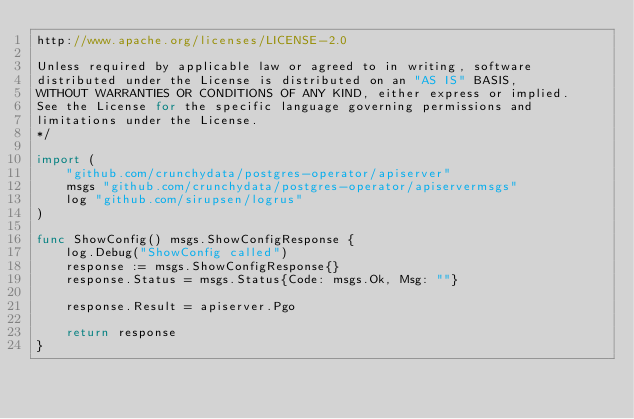Convert code to text. <code><loc_0><loc_0><loc_500><loc_500><_Go_>http://www.apache.org/licenses/LICENSE-2.0

Unless required by applicable law or agreed to in writing, software
distributed under the License is distributed on an "AS IS" BASIS,
WITHOUT WARRANTIES OR CONDITIONS OF ANY KIND, either express or implied.
See the License for the specific language governing permissions and
limitations under the License.
*/

import (
	"github.com/crunchydata/postgres-operator/apiserver"
	msgs "github.com/crunchydata/postgres-operator/apiservermsgs"
	log "github.com/sirupsen/logrus"
)

func ShowConfig() msgs.ShowConfigResponse {
	log.Debug("ShowConfig called")
	response := msgs.ShowConfigResponse{}
	response.Status = msgs.Status{Code: msgs.Ok, Msg: ""}

	response.Result = apiserver.Pgo

	return response
}
</code> 